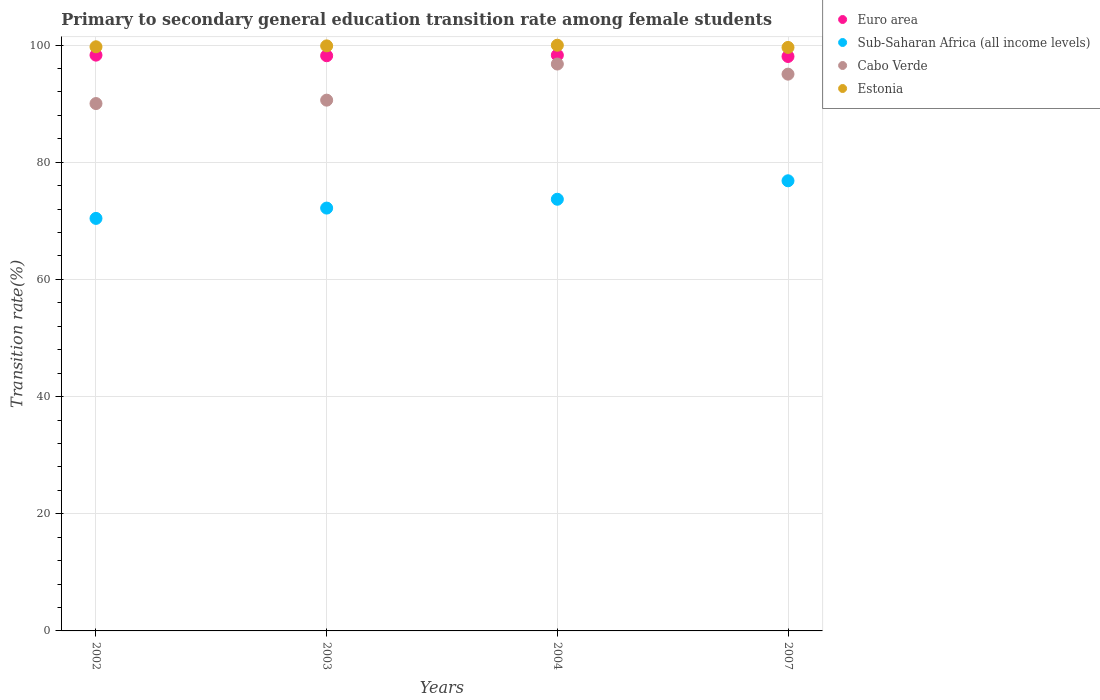What is the transition rate in Estonia in 2002?
Make the answer very short. 99.7. Across all years, what is the maximum transition rate in Euro area?
Your response must be concise. 98.28. Across all years, what is the minimum transition rate in Cabo Verde?
Keep it short and to the point. 90.01. What is the total transition rate in Sub-Saharan Africa (all income levels) in the graph?
Make the answer very short. 293.09. What is the difference between the transition rate in Euro area in 2002 and that in 2003?
Offer a very short reply. 0.1. What is the difference between the transition rate in Euro area in 2004 and the transition rate in Cabo Verde in 2002?
Your answer should be very brief. 8.26. What is the average transition rate in Cabo Verde per year?
Ensure brevity in your answer.  93.1. In the year 2002, what is the difference between the transition rate in Euro area and transition rate in Estonia?
Offer a very short reply. -1.42. What is the ratio of the transition rate in Sub-Saharan Africa (all income levels) in 2002 to that in 2007?
Ensure brevity in your answer.  0.92. What is the difference between the highest and the second highest transition rate in Cabo Verde?
Make the answer very short. 1.73. What is the difference between the highest and the lowest transition rate in Estonia?
Provide a succinct answer. 0.37. In how many years, is the transition rate in Estonia greater than the average transition rate in Estonia taken over all years?
Offer a very short reply. 2. How many dotlines are there?
Your answer should be compact. 4. How many years are there in the graph?
Give a very brief answer. 4. What is the difference between two consecutive major ticks on the Y-axis?
Provide a succinct answer. 20. Are the values on the major ticks of Y-axis written in scientific E-notation?
Your answer should be compact. No. Where does the legend appear in the graph?
Offer a terse response. Top right. How many legend labels are there?
Your response must be concise. 4. How are the legend labels stacked?
Give a very brief answer. Vertical. What is the title of the graph?
Your answer should be compact. Primary to secondary general education transition rate among female students. What is the label or title of the X-axis?
Your answer should be compact. Years. What is the label or title of the Y-axis?
Keep it short and to the point. Transition rate(%). What is the Transition rate(%) of Euro area in 2002?
Offer a very short reply. 98.28. What is the Transition rate(%) of Sub-Saharan Africa (all income levels) in 2002?
Offer a very short reply. 70.41. What is the Transition rate(%) of Cabo Verde in 2002?
Your answer should be compact. 90.01. What is the Transition rate(%) of Estonia in 2002?
Your answer should be very brief. 99.7. What is the Transition rate(%) in Euro area in 2003?
Your answer should be compact. 98.17. What is the Transition rate(%) of Sub-Saharan Africa (all income levels) in 2003?
Give a very brief answer. 72.17. What is the Transition rate(%) of Cabo Verde in 2003?
Your response must be concise. 90.59. What is the Transition rate(%) of Estonia in 2003?
Give a very brief answer. 99.86. What is the Transition rate(%) of Euro area in 2004?
Your response must be concise. 98.27. What is the Transition rate(%) of Sub-Saharan Africa (all income levels) in 2004?
Offer a terse response. 73.68. What is the Transition rate(%) of Cabo Verde in 2004?
Offer a terse response. 96.76. What is the Transition rate(%) in Estonia in 2004?
Provide a succinct answer. 99.97. What is the Transition rate(%) of Euro area in 2007?
Ensure brevity in your answer.  98.05. What is the Transition rate(%) in Sub-Saharan Africa (all income levels) in 2007?
Provide a short and direct response. 76.83. What is the Transition rate(%) in Cabo Verde in 2007?
Your answer should be very brief. 95.03. What is the Transition rate(%) in Estonia in 2007?
Ensure brevity in your answer.  99.59. Across all years, what is the maximum Transition rate(%) in Euro area?
Make the answer very short. 98.28. Across all years, what is the maximum Transition rate(%) in Sub-Saharan Africa (all income levels)?
Your answer should be very brief. 76.83. Across all years, what is the maximum Transition rate(%) in Cabo Verde?
Provide a succinct answer. 96.76. Across all years, what is the maximum Transition rate(%) of Estonia?
Ensure brevity in your answer.  99.97. Across all years, what is the minimum Transition rate(%) in Euro area?
Provide a short and direct response. 98.05. Across all years, what is the minimum Transition rate(%) of Sub-Saharan Africa (all income levels)?
Offer a very short reply. 70.41. Across all years, what is the minimum Transition rate(%) in Cabo Verde?
Offer a terse response. 90.01. Across all years, what is the minimum Transition rate(%) in Estonia?
Give a very brief answer. 99.59. What is the total Transition rate(%) in Euro area in the graph?
Your answer should be compact. 392.77. What is the total Transition rate(%) in Sub-Saharan Africa (all income levels) in the graph?
Ensure brevity in your answer.  293.09. What is the total Transition rate(%) of Cabo Verde in the graph?
Offer a terse response. 372.39. What is the total Transition rate(%) in Estonia in the graph?
Provide a succinct answer. 399.12. What is the difference between the Transition rate(%) in Euro area in 2002 and that in 2003?
Your answer should be very brief. 0.1. What is the difference between the Transition rate(%) in Sub-Saharan Africa (all income levels) in 2002 and that in 2003?
Offer a terse response. -1.76. What is the difference between the Transition rate(%) of Cabo Verde in 2002 and that in 2003?
Ensure brevity in your answer.  -0.58. What is the difference between the Transition rate(%) of Estonia in 2002 and that in 2003?
Your answer should be compact. -0.16. What is the difference between the Transition rate(%) of Euro area in 2002 and that in 2004?
Make the answer very short. 0.01. What is the difference between the Transition rate(%) in Sub-Saharan Africa (all income levels) in 2002 and that in 2004?
Offer a very short reply. -3.27. What is the difference between the Transition rate(%) of Cabo Verde in 2002 and that in 2004?
Your response must be concise. -6.75. What is the difference between the Transition rate(%) in Estonia in 2002 and that in 2004?
Provide a succinct answer. -0.27. What is the difference between the Transition rate(%) in Euro area in 2002 and that in 2007?
Keep it short and to the point. 0.23. What is the difference between the Transition rate(%) in Sub-Saharan Africa (all income levels) in 2002 and that in 2007?
Your answer should be compact. -6.42. What is the difference between the Transition rate(%) of Cabo Verde in 2002 and that in 2007?
Provide a short and direct response. -5.02. What is the difference between the Transition rate(%) in Estonia in 2002 and that in 2007?
Give a very brief answer. 0.11. What is the difference between the Transition rate(%) in Euro area in 2003 and that in 2004?
Offer a very short reply. -0.1. What is the difference between the Transition rate(%) in Sub-Saharan Africa (all income levels) in 2003 and that in 2004?
Ensure brevity in your answer.  -1.51. What is the difference between the Transition rate(%) of Cabo Verde in 2003 and that in 2004?
Your answer should be very brief. -6.17. What is the difference between the Transition rate(%) of Estonia in 2003 and that in 2004?
Make the answer very short. -0.11. What is the difference between the Transition rate(%) in Euro area in 2003 and that in 2007?
Ensure brevity in your answer.  0.12. What is the difference between the Transition rate(%) in Sub-Saharan Africa (all income levels) in 2003 and that in 2007?
Ensure brevity in your answer.  -4.66. What is the difference between the Transition rate(%) of Cabo Verde in 2003 and that in 2007?
Ensure brevity in your answer.  -4.44. What is the difference between the Transition rate(%) of Estonia in 2003 and that in 2007?
Ensure brevity in your answer.  0.26. What is the difference between the Transition rate(%) in Euro area in 2004 and that in 2007?
Your answer should be compact. 0.22. What is the difference between the Transition rate(%) in Sub-Saharan Africa (all income levels) in 2004 and that in 2007?
Make the answer very short. -3.15. What is the difference between the Transition rate(%) in Cabo Verde in 2004 and that in 2007?
Ensure brevity in your answer.  1.73. What is the difference between the Transition rate(%) in Estonia in 2004 and that in 2007?
Keep it short and to the point. 0.37. What is the difference between the Transition rate(%) of Euro area in 2002 and the Transition rate(%) of Sub-Saharan Africa (all income levels) in 2003?
Make the answer very short. 26.11. What is the difference between the Transition rate(%) of Euro area in 2002 and the Transition rate(%) of Cabo Verde in 2003?
Give a very brief answer. 7.68. What is the difference between the Transition rate(%) of Euro area in 2002 and the Transition rate(%) of Estonia in 2003?
Provide a short and direct response. -1.58. What is the difference between the Transition rate(%) in Sub-Saharan Africa (all income levels) in 2002 and the Transition rate(%) in Cabo Verde in 2003?
Make the answer very short. -20.18. What is the difference between the Transition rate(%) of Sub-Saharan Africa (all income levels) in 2002 and the Transition rate(%) of Estonia in 2003?
Your answer should be very brief. -29.45. What is the difference between the Transition rate(%) in Cabo Verde in 2002 and the Transition rate(%) in Estonia in 2003?
Give a very brief answer. -9.84. What is the difference between the Transition rate(%) in Euro area in 2002 and the Transition rate(%) in Sub-Saharan Africa (all income levels) in 2004?
Make the answer very short. 24.6. What is the difference between the Transition rate(%) in Euro area in 2002 and the Transition rate(%) in Cabo Verde in 2004?
Your answer should be very brief. 1.52. What is the difference between the Transition rate(%) in Euro area in 2002 and the Transition rate(%) in Estonia in 2004?
Your answer should be compact. -1.69. What is the difference between the Transition rate(%) of Sub-Saharan Africa (all income levels) in 2002 and the Transition rate(%) of Cabo Verde in 2004?
Provide a succinct answer. -26.35. What is the difference between the Transition rate(%) in Sub-Saharan Africa (all income levels) in 2002 and the Transition rate(%) in Estonia in 2004?
Your answer should be very brief. -29.56. What is the difference between the Transition rate(%) of Cabo Verde in 2002 and the Transition rate(%) of Estonia in 2004?
Offer a very short reply. -9.95. What is the difference between the Transition rate(%) in Euro area in 2002 and the Transition rate(%) in Sub-Saharan Africa (all income levels) in 2007?
Offer a terse response. 21.45. What is the difference between the Transition rate(%) in Euro area in 2002 and the Transition rate(%) in Cabo Verde in 2007?
Make the answer very short. 3.24. What is the difference between the Transition rate(%) in Euro area in 2002 and the Transition rate(%) in Estonia in 2007?
Provide a short and direct response. -1.32. What is the difference between the Transition rate(%) in Sub-Saharan Africa (all income levels) in 2002 and the Transition rate(%) in Cabo Verde in 2007?
Make the answer very short. -24.62. What is the difference between the Transition rate(%) of Sub-Saharan Africa (all income levels) in 2002 and the Transition rate(%) of Estonia in 2007?
Your response must be concise. -29.18. What is the difference between the Transition rate(%) in Cabo Verde in 2002 and the Transition rate(%) in Estonia in 2007?
Give a very brief answer. -9.58. What is the difference between the Transition rate(%) in Euro area in 2003 and the Transition rate(%) in Sub-Saharan Africa (all income levels) in 2004?
Give a very brief answer. 24.49. What is the difference between the Transition rate(%) in Euro area in 2003 and the Transition rate(%) in Cabo Verde in 2004?
Your response must be concise. 1.42. What is the difference between the Transition rate(%) in Euro area in 2003 and the Transition rate(%) in Estonia in 2004?
Ensure brevity in your answer.  -1.79. What is the difference between the Transition rate(%) in Sub-Saharan Africa (all income levels) in 2003 and the Transition rate(%) in Cabo Verde in 2004?
Ensure brevity in your answer.  -24.59. What is the difference between the Transition rate(%) in Sub-Saharan Africa (all income levels) in 2003 and the Transition rate(%) in Estonia in 2004?
Your answer should be compact. -27.8. What is the difference between the Transition rate(%) of Cabo Verde in 2003 and the Transition rate(%) of Estonia in 2004?
Keep it short and to the point. -9.37. What is the difference between the Transition rate(%) in Euro area in 2003 and the Transition rate(%) in Sub-Saharan Africa (all income levels) in 2007?
Keep it short and to the point. 21.34. What is the difference between the Transition rate(%) in Euro area in 2003 and the Transition rate(%) in Cabo Verde in 2007?
Your answer should be compact. 3.14. What is the difference between the Transition rate(%) of Euro area in 2003 and the Transition rate(%) of Estonia in 2007?
Provide a succinct answer. -1.42. What is the difference between the Transition rate(%) in Sub-Saharan Africa (all income levels) in 2003 and the Transition rate(%) in Cabo Verde in 2007?
Offer a terse response. -22.86. What is the difference between the Transition rate(%) of Sub-Saharan Africa (all income levels) in 2003 and the Transition rate(%) of Estonia in 2007?
Your response must be concise. -27.42. What is the difference between the Transition rate(%) of Cabo Verde in 2003 and the Transition rate(%) of Estonia in 2007?
Provide a succinct answer. -9. What is the difference between the Transition rate(%) in Euro area in 2004 and the Transition rate(%) in Sub-Saharan Africa (all income levels) in 2007?
Provide a succinct answer. 21.44. What is the difference between the Transition rate(%) of Euro area in 2004 and the Transition rate(%) of Cabo Verde in 2007?
Provide a succinct answer. 3.24. What is the difference between the Transition rate(%) of Euro area in 2004 and the Transition rate(%) of Estonia in 2007?
Provide a short and direct response. -1.32. What is the difference between the Transition rate(%) of Sub-Saharan Africa (all income levels) in 2004 and the Transition rate(%) of Cabo Verde in 2007?
Make the answer very short. -21.35. What is the difference between the Transition rate(%) in Sub-Saharan Africa (all income levels) in 2004 and the Transition rate(%) in Estonia in 2007?
Ensure brevity in your answer.  -25.91. What is the difference between the Transition rate(%) of Cabo Verde in 2004 and the Transition rate(%) of Estonia in 2007?
Provide a short and direct response. -2.83. What is the average Transition rate(%) of Euro area per year?
Ensure brevity in your answer.  98.19. What is the average Transition rate(%) in Sub-Saharan Africa (all income levels) per year?
Your answer should be compact. 73.27. What is the average Transition rate(%) in Cabo Verde per year?
Keep it short and to the point. 93.1. What is the average Transition rate(%) in Estonia per year?
Keep it short and to the point. 99.78. In the year 2002, what is the difference between the Transition rate(%) of Euro area and Transition rate(%) of Sub-Saharan Africa (all income levels)?
Your response must be concise. 27.87. In the year 2002, what is the difference between the Transition rate(%) of Euro area and Transition rate(%) of Cabo Verde?
Ensure brevity in your answer.  8.26. In the year 2002, what is the difference between the Transition rate(%) in Euro area and Transition rate(%) in Estonia?
Your answer should be very brief. -1.42. In the year 2002, what is the difference between the Transition rate(%) of Sub-Saharan Africa (all income levels) and Transition rate(%) of Cabo Verde?
Keep it short and to the point. -19.6. In the year 2002, what is the difference between the Transition rate(%) of Sub-Saharan Africa (all income levels) and Transition rate(%) of Estonia?
Offer a terse response. -29.29. In the year 2002, what is the difference between the Transition rate(%) in Cabo Verde and Transition rate(%) in Estonia?
Provide a succinct answer. -9.69. In the year 2003, what is the difference between the Transition rate(%) in Euro area and Transition rate(%) in Sub-Saharan Africa (all income levels)?
Your response must be concise. 26. In the year 2003, what is the difference between the Transition rate(%) in Euro area and Transition rate(%) in Cabo Verde?
Make the answer very short. 7.58. In the year 2003, what is the difference between the Transition rate(%) of Euro area and Transition rate(%) of Estonia?
Provide a succinct answer. -1.68. In the year 2003, what is the difference between the Transition rate(%) in Sub-Saharan Africa (all income levels) and Transition rate(%) in Cabo Verde?
Keep it short and to the point. -18.42. In the year 2003, what is the difference between the Transition rate(%) in Sub-Saharan Africa (all income levels) and Transition rate(%) in Estonia?
Provide a short and direct response. -27.69. In the year 2003, what is the difference between the Transition rate(%) of Cabo Verde and Transition rate(%) of Estonia?
Your answer should be compact. -9.26. In the year 2004, what is the difference between the Transition rate(%) in Euro area and Transition rate(%) in Sub-Saharan Africa (all income levels)?
Provide a succinct answer. 24.59. In the year 2004, what is the difference between the Transition rate(%) of Euro area and Transition rate(%) of Cabo Verde?
Keep it short and to the point. 1.51. In the year 2004, what is the difference between the Transition rate(%) in Euro area and Transition rate(%) in Estonia?
Offer a very short reply. -1.7. In the year 2004, what is the difference between the Transition rate(%) of Sub-Saharan Africa (all income levels) and Transition rate(%) of Cabo Verde?
Your answer should be compact. -23.08. In the year 2004, what is the difference between the Transition rate(%) in Sub-Saharan Africa (all income levels) and Transition rate(%) in Estonia?
Provide a short and direct response. -26.29. In the year 2004, what is the difference between the Transition rate(%) of Cabo Verde and Transition rate(%) of Estonia?
Keep it short and to the point. -3.21. In the year 2007, what is the difference between the Transition rate(%) of Euro area and Transition rate(%) of Sub-Saharan Africa (all income levels)?
Offer a terse response. 21.22. In the year 2007, what is the difference between the Transition rate(%) of Euro area and Transition rate(%) of Cabo Verde?
Make the answer very short. 3.02. In the year 2007, what is the difference between the Transition rate(%) of Euro area and Transition rate(%) of Estonia?
Your response must be concise. -1.54. In the year 2007, what is the difference between the Transition rate(%) of Sub-Saharan Africa (all income levels) and Transition rate(%) of Cabo Verde?
Your answer should be compact. -18.2. In the year 2007, what is the difference between the Transition rate(%) in Sub-Saharan Africa (all income levels) and Transition rate(%) in Estonia?
Ensure brevity in your answer.  -22.76. In the year 2007, what is the difference between the Transition rate(%) of Cabo Verde and Transition rate(%) of Estonia?
Make the answer very short. -4.56. What is the ratio of the Transition rate(%) of Euro area in 2002 to that in 2003?
Offer a terse response. 1. What is the ratio of the Transition rate(%) in Sub-Saharan Africa (all income levels) in 2002 to that in 2003?
Make the answer very short. 0.98. What is the ratio of the Transition rate(%) in Cabo Verde in 2002 to that in 2003?
Your answer should be compact. 0.99. What is the ratio of the Transition rate(%) in Sub-Saharan Africa (all income levels) in 2002 to that in 2004?
Offer a terse response. 0.96. What is the ratio of the Transition rate(%) in Cabo Verde in 2002 to that in 2004?
Make the answer very short. 0.93. What is the ratio of the Transition rate(%) in Euro area in 2002 to that in 2007?
Give a very brief answer. 1. What is the ratio of the Transition rate(%) in Sub-Saharan Africa (all income levels) in 2002 to that in 2007?
Provide a short and direct response. 0.92. What is the ratio of the Transition rate(%) in Cabo Verde in 2002 to that in 2007?
Provide a short and direct response. 0.95. What is the ratio of the Transition rate(%) in Estonia in 2002 to that in 2007?
Offer a terse response. 1. What is the ratio of the Transition rate(%) in Sub-Saharan Africa (all income levels) in 2003 to that in 2004?
Keep it short and to the point. 0.98. What is the ratio of the Transition rate(%) of Cabo Verde in 2003 to that in 2004?
Your answer should be compact. 0.94. What is the ratio of the Transition rate(%) in Estonia in 2003 to that in 2004?
Ensure brevity in your answer.  1. What is the ratio of the Transition rate(%) in Euro area in 2003 to that in 2007?
Your answer should be compact. 1. What is the ratio of the Transition rate(%) in Sub-Saharan Africa (all income levels) in 2003 to that in 2007?
Offer a very short reply. 0.94. What is the ratio of the Transition rate(%) in Cabo Verde in 2003 to that in 2007?
Give a very brief answer. 0.95. What is the ratio of the Transition rate(%) of Estonia in 2003 to that in 2007?
Offer a very short reply. 1. What is the ratio of the Transition rate(%) of Euro area in 2004 to that in 2007?
Your answer should be very brief. 1. What is the ratio of the Transition rate(%) of Cabo Verde in 2004 to that in 2007?
Your answer should be very brief. 1.02. What is the difference between the highest and the second highest Transition rate(%) in Euro area?
Your answer should be compact. 0.01. What is the difference between the highest and the second highest Transition rate(%) of Sub-Saharan Africa (all income levels)?
Ensure brevity in your answer.  3.15. What is the difference between the highest and the second highest Transition rate(%) of Cabo Verde?
Your answer should be very brief. 1.73. What is the difference between the highest and the second highest Transition rate(%) of Estonia?
Your response must be concise. 0.11. What is the difference between the highest and the lowest Transition rate(%) in Euro area?
Your response must be concise. 0.23. What is the difference between the highest and the lowest Transition rate(%) of Sub-Saharan Africa (all income levels)?
Give a very brief answer. 6.42. What is the difference between the highest and the lowest Transition rate(%) of Cabo Verde?
Keep it short and to the point. 6.75. What is the difference between the highest and the lowest Transition rate(%) in Estonia?
Your answer should be very brief. 0.37. 